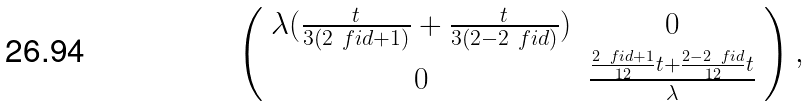Convert formula to latex. <formula><loc_0><loc_0><loc_500><loc_500>\left ( \begin{array} { c c } \lambda ( \frac { t } { 3 ( 2 \ f i d + 1 ) } + \frac { t } { 3 ( 2 - 2 \ f i d ) } ) & 0 \\ 0 & \frac { \frac { 2 \ f i d + 1 } { 1 2 } t + \frac { 2 - 2 \ f i d } { 1 2 } t } { \lambda } \end{array} \right ) ,</formula> 